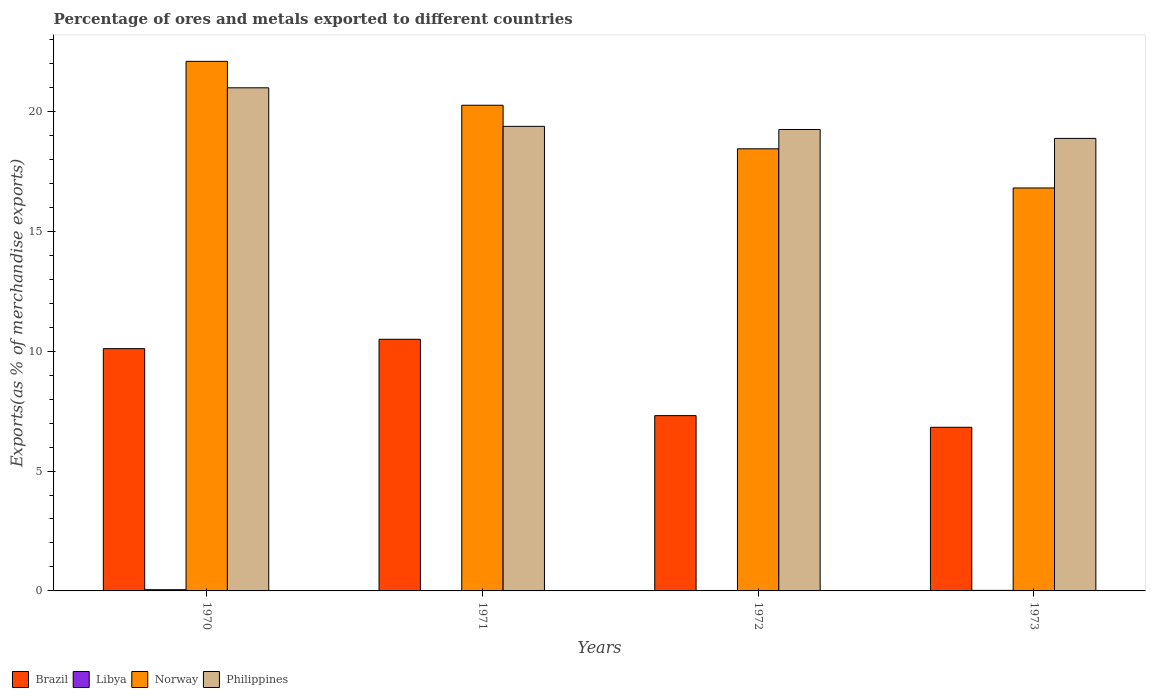How many different coloured bars are there?
Your response must be concise. 4. How many groups of bars are there?
Give a very brief answer. 4. How many bars are there on the 3rd tick from the left?
Your answer should be very brief. 4. What is the label of the 1st group of bars from the left?
Your response must be concise. 1970. What is the percentage of exports to different countries in Brazil in 1972?
Keep it short and to the point. 7.31. Across all years, what is the maximum percentage of exports to different countries in Libya?
Make the answer very short. 0.05. Across all years, what is the minimum percentage of exports to different countries in Philippines?
Make the answer very short. 18.87. In which year was the percentage of exports to different countries in Norway maximum?
Make the answer very short. 1970. What is the total percentage of exports to different countries in Libya in the graph?
Provide a succinct answer. 0.1. What is the difference between the percentage of exports to different countries in Norway in 1972 and that in 1973?
Provide a short and direct response. 1.63. What is the difference between the percentage of exports to different countries in Norway in 1970 and the percentage of exports to different countries in Brazil in 1971?
Keep it short and to the point. 11.59. What is the average percentage of exports to different countries in Philippines per year?
Make the answer very short. 19.62. In the year 1970, what is the difference between the percentage of exports to different countries in Brazil and percentage of exports to different countries in Libya?
Provide a succinct answer. 10.05. In how many years, is the percentage of exports to different countries in Libya greater than 13 %?
Your answer should be very brief. 0. What is the ratio of the percentage of exports to different countries in Philippines in 1970 to that in 1973?
Your answer should be compact. 1.11. Is the percentage of exports to different countries in Philippines in 1971 less than that in 1972?
Give a very brief answer. No. Is the difference between the percentage of exports to different countries in Brazil in 1972 and 1973 greater than the difference between the percentage of exports to different countries in Libya in 1972 and 1973?
Keep it short and to the point. Yes. What is the difference between the highest and the second highest percentage of exports to different countries in Philippines?
Offer a very short reply. 1.61. What is the difference between the highest and the lowest percentage of exports to different countries in Libya?
Provide a succinct answer. 0.05. In how many years, is the percentage of exports to different countries in Libya greater than the average percentage of exports to different countries in Libya taken over all years?
Provide a short and direct response. 1. Is the sum of the percentage of exports to different countries in Libya in 1971 and 1973 greater than the maximum percentage of exports to different countries in Philippines across all years?
Give a very brief answer. No. What does the 2nd bar from the left in 1973 represents?
Make the answer very short. Libya. What does the 3rd bar from the right in 1970 represents?
Provide a succinct answer. Libya. Is it the case that in every year, the sum of the percentage of exports to different countries in Libya and percentage of exports to different countries in Philippines is greater than the percentage of exports to different countries in Brazil?
Give a very brief answer. Yes. How many years are there in the graph?
Your response must be concise. 4. What is the difference between two consecutive major ticks on the Y-axis?
Your response must be concise. 5. Are the values on the major ticks of Y-axis written in scientific E-notation?
Give a very brief answer. No. Where does the legend appear in the graph?
Provide a short and direct response. Bottom left. How many legend labels are there?
Make the answer very short. 4. What is the title of the graph?
Offer a terse response. Percentage of ores and metals exported to different countries. What is the label or title of the X-axis?
Make the answer very short. Years. What is the label or title of the Y-axis?
Your answer should be very brief. Exports(as % of merchandise exports). What is the Exports(as % of merchandise exports) in Brazil in 1970?
Give a very brief answer. 10.11. What is the Exports(as % of merchandise exports) of Libya in 1970?
Your response must be concise. 0.05. What is the Exports(as % of merchandise exports) in Norway in 1970?
Ensure brevity in your answer.  22.09. What is the Exports(as % of merchandise exports) in Philippines in 1970?
Ensure brevity in your answer.  20.98. What is the Exports(as % of merchandise exports) of Brazil in 1971?
Make the answer very short. 10.5. What is the Exports(as % of merchandise exports) in Libya in 1971?
Offer a very short reply. 0. What is the Exports(as % of merchandise exports) of Norway in 1971?
Your answer should be compact. 20.26. What is the Exports(as % of merchandise exports) of Philippines in 1971?
Provide a succinct answer. 19.38. What is the Exports(as % of merchandise exports) of Brazil in 1972?
Keep it short and to the point. 7.31. What is the Exports(as % of merchandise exports) of Libya in 1972?
Your answer should be compact. 0.02. What is the Exports(as % of merchandise exports) in Norway in 1972?
Your response must be concise. 18.44. What is the Exports(as % of merchandise exports) in Philippines in 1972?
Your answer should be compact. 19.25. What is the Exports(as % of merchandise exports) in Brazil in 1973?
Your answer should be very brief. 6.83. What is the Exports(as % of merchandise exports) in Libya in 1973?
Your answer should be very brief. 0.02. What is the Exports(as % of merchandise exports) of Norway in 1973?
Provide a short and direct response. 16.81. What is the Exports(as % of merchandise exports) in Philippines in 1973?
Your response must be concise. 18.87. Across all years, what is the maximum Exports(as % of merchandise exports) in Brazil?
Ensure brevity in your answer.  10.5. Across all years, what is the maximum Exports(as % of merchandise exports) in Libya?
Ensure brevity in your answer.  0.05. Across all years, what is the maximum Exports(as % of merchandise exports) of Norway?
Your answer should be very brief. 22.09. Across all years, what is the maximum Exports(as % of merchandise exports) of Philippines?
Ensure brevity in your answer.  20.98. Across all years, what is the minimum Exports(as % of merchandise exports) of Brazil?
Your response must be concise. 6.83. Across all years, what is the minimum Exports(as % of merchandise exports) in Libya?
Provide a short and direct response. 0. Across all years, what is the minimum Exports(as % of merchandise exports) of Norway?
Your answer should be very brief. 16.81. Across all years, what is the minimum Exports(as % of merchandise exports) in Philippines?
Provide a succinct answer. 18.87. What is the total Exports(as % of merchandise exports) of Brazil in the graph?
Your response must be concise. 34.74. What is the total Exports(as % of merchandise exports) of Libya in the graph?
Keep it short and to the point. 0.1. What is the total Exports(as % of merchandise exports) of Norway in the graph?
Ensure brevity in your answer.  77.59. What is the total Exports(as % of merchandise exports) in Philippines in the graph?
Your answer should be very brief. 78.48. What is the difference between the Exports(as % of merchandise exports) in Brazil in 1970 and that in 1971?
Provide a short and direct response. -0.39. What is the difference between the Exports(as % of merchandise exports) of Libya in 1970 and that in 1971?
Offer a terse response. 0.05. What is the difference between the Exports(as % of merchandise exports) of Norway in 1970 and that in 1971?
Your answer should be very brief. 1.83. What is the difference between the Exports(as % of merchandise exports) in Philippines in 1970 and that in 1971?
Make the answer very short. 1.61. What is the difference between the Exports(as % of merchandise exports) of Brazil in 1970 and that in 1972?
Offer a very short reply. 2.79. What is the difference between the Exports(as % of merchandise exports) in Libya in 1970 and that in 1972?
Ensure brevity in your answer.  0.03. What is the difference between the Exports(as % of merchandise exports) of Norway in 1970 and that in 1972?
Keep it short and to the point. 3.65. What is the difference between the Exports(as % of merchandise exports) in Philippines in 1970 and that in 1972?
Your answer should be very brief. 1.74. What is the difference between the Exports(as % of merchandise exports) of Brazil in 1970 and that in 1973?
Ensure brevity in your answer.  3.28. What is the difference between the Exports(as % of merchandise exports) in Libya in 1970 and that in 1973?
Provide a succinct answer. 0.03. What is the difference between the Exports(as % of merchandise exports) of Norway in 1970 and that in 1973?
Your answer should be compact. 5.28. What is the difference between the Exports(as % of merchandise exports) in Philippines in 1970 and that in 1973?
Ensure brevity in your answer.  2.11. What is the difference between the Exports(as % of merchandise exports) in Brazil in 1971 and that in 1972?
Your answer should be compact. 3.18. What is the difference between the Exports(as % of merchandise exports) in Libya in 1971 and that in 1972?
Make the answer very short. -0.01. What is the difference between the Exports(as % of merchandise exports) of Norway in 1971 and that in 1972?
Give a very brief answer. 1.82. What is the difference between the Exports(as % of merchandise exports) of Philippines in 1971 and that in 1972?
Make the answer very short. 0.13. What is the difference between the Exports(as % of merchandise exports) in Brazil in 1971 and that in 1973?
Your response must be concise. 3.67. What is the difference between the Exports(as % of merchandise exports) of Libya in 1971 and that in 1973?
Keep it short and to the point. -0.02. What is the difference between the Exports(as % of merchandise exports) of Norway in 1971 and that in 1973?
Offer a terse response. 3.45. What is the difference between the Exports(as % of merchandise exports) in Philippines in 1971 and that in 1973?
Offer a terse response. 0.5. What is the difference between the Exports(as % of merchandise exports) of Brazil in 1972 and that in 1973?
Offer a terse response. 0.49. What is the difference between the Exports(as % of merchandise exports) in Libya in 1972 and that in 1973?
Ensure brevity in your answer.  -0. What is the difference between the Exports(as % of merchandise exports) of Norway in 1972 and that in 1973?
Your answer should be very brief. 1.63. What is the difference between the Exports(as % of merchandise exports) in Philippines in 1972 and that in 1973?
Your answer should be compact. 0.37. What is the difference between the Exports(as % of merchandise exports) of Brazil in 1970 and the Exports(as % of merchandise exports) of Libya in 1971?
Ensure brevity in your answer.  10.1. What is the difference between the Exports(as % of merchandise exports) of Brazil in 1970 and the Exports(as % of merchandise exports) of Norway in 1971?
Give a very brief answer. -10.15. What is the difference between the Exports(as % of merchandise exports) of Brazil in 1970 and the Exports(as % of merchandise exports) of Philippines in 1971?
Provide a short and direct response. -9.27. What is the difference between the Exports(as % of merchandise exports) in Libya in 1970 and the Exports(as % of merchandise exports) in Norway in 1971?
Give a very brief answer. -20.21. What is the difference between the Exports(as % of merchandise exports) in Libya in 1970 and the Exports(as % of merchandise exports) in Philippines in 1971?
Ensure brevity in your answer.  -19.33. What is the difference between the Exports(as % of merchandise exports) of Norway in 1970 and the Exports(as % of merchandise exports) of Philippines in 1971?
Keep it short and to the point. 2.71. What is the difference between the Exports(as % of merchandise exports) of Brazil in 1970 and the Exports(as % of merchandise exports) of Libya in 1972?
Your response must be concise. 10.09. What is the difference between the Exports(as % of merchandise exports) of Brazil in 1970 and the Exports(as % of merchandise exports) of Norway in 1972?
Keep it short and to the point. -8.34. What is the difference between the Exports(as % of merchandise exports) in Brazil in 1970 and the Exports(as % of merchandise exports) in Philippines in 1972?
Your answer should be compact. -9.14. What is the difference between the Exports(as % of merchandise exports) in Libya in 1970 and the Exports(as % of merchandise exports) in Norway in 1972?
Offer a terse response. -18.39. What is the difference between the Exports(as % of merchandise exports) in Libya in 1970 and the Exports(as % of merchandise exports) in Philippines in 1972?
Give a very brief answer. -19.19. What is the difference between the Exports(as % of merchandise exports) of Norway in 1970 and the Exports(as % of merchandise exports) of Philippines in 1972?
Give a very brief answer. 2.84. What is the difference between the Exports(as % of merchandise exports) in Brazil in 1970 and the Exports(as % of merchandise exports) in Libya in 1973?
Your answer should be compact. 10.08. What is the difference between the Exports(as % of merchandise exports) in Brazil in 1970 and the Exports(as % of merchandise exports) in Norway in 1973?
Offer a very short reply. -6.7. What is the difference between the Exports(as % of merchandise exports) in Brazil in 1970 and the Exports(as % of merchandise exports) in Philippines in 1973?
Make the answer very short. -8.77. What is the difference between the Exports(as % of merchandise exports) of Libya in 1970 and the Exports(as % of merchandise exports) of Norway in 1973?
Your answer should be compact. -16.75. What is the difference between the Exports(as % of merchandise exports) in Libya in 1970 and the Exports(as % of merchandise exports) in Philippines in 1973?
Provide a succinct answer. -18.82. What is the difference between the Exports(as % of merchandise exports) of Norway in 1970 and the Exports(as % of merchandise exports) of Philippines in 1973?
Provide a succinct answer. 3.21. What is the difference between the Exports(as % of merchandise exports) in Brazil in 1971 and the Exports(as % of merchandise exports) in Libya in 1972?
Provide a short and direct response. 10.48. What is the difference between the Exports(as % of merchandise exports) in Brazil in 1971 and the Exports(as % of merchandise exports) in Norway in 1972?
Keep it short and to the point. -7.94. What is the difference between the Exports(as % of merchandise exports) in Brazil in 1971 and the Exports(as % of merchandise exports) in Philippines in 1972?
Your answer should be compact. -8.75. What is the difference between the Exports(as % of merchandise exports) of Libya in 1971 and the Exports(as % of merchandise exports) of Norway in 1972?
Offer a terse response. -18.44. What is the difference between the Exports(as % of merchandise exports) in Libya in 1971 and the Exports(as % of merchandise exports) in Philippines in 1972?
Ensure brevity in your answer.  -19.24. What is the difference between the Exports(as % of merchandise exports) in Brazil in 1971 and the Exports(as % of merchandise exports) in Libya in 1973?
Your answer should be very brief. 10.47. What is the difference between the Exports(as % of merchandise exports) in Brazil in 1971 and the Exports(as % of merchandise exports) in Norway in 1973?
Make the answer very short. -6.31. What is the difference between the Exports(as % of merchandise exports) in Brazil in 1971 and the Exports(as % of merchandise exports) in Philippines in 1973?
Give a very brief answer. -8.38. What is the difference between the Exports(as % of merchandise exports) in Libya in 1971 and the Exports(as % of merchandise exports) in Norway in 1973?
Provide a succinct answer. -16.8. What is the difference between the Exports(as % of merchandise exports) in Libya in 1971 and the Exports(as % of merchandise exports) in Philippines in 1973?
Give a very brief answer. -18.87. What is the difference between the Exports(as % of merchandise exports) of Norway in 1971 and the Exports(as % of merchandise exports) of Philippines in 1973?
Your response must be concise. 1.38. What is the difference between the Exports(as % of merchandise exports) of Brazil in 1972 and the Exports(as % of merchandise exports) of Libya in 1973?
Give a very brief answer. 7.29. What is the difference between the Exports(as % of merchandise exports) in Brazil in 1972 and the Exports(as % of merchandise exports) in Norway in 1973?
Give a very brief answer. -9.49. What is the difference between the Exports(as % of merchandise exports) in Brazil in 1972 and the Exports(as % of merchandise exports) in Philippines in 1973?
Offer a terse response. -11.56. What is the difference between the Exports(as % of merchandise exports) in Libya in 1972 and the Exports(as % of merchandise exports) in Norway in 1973?
Offer a terse response. -16.79. What is the difference between the Exports(as % of merchandise exports) in Libya in 1972 and the Exports(as % of merchandise exports) in Philippines in 1973?
Ensure brevity in your answer.  -18.86. What is the difference between the Exports(as % of merchandise exports) of Norway in 1972 and the Exports(as % of merchandise exports) of Philippines in 1973?
Provide a succinct answer. -0.43. What is the average Exports(as % of merchandise exports) in Brazil per year?
Your response must be concise. 8.68. What is the average Exports(as % of merchandise exports) of Libya per year?
Give a very brief answer. 0.02. What is the average Exports(as % of merchandise exports) of Norway per year?
Your answer should be compact. 19.4. What is the average Exports(as % of merchandise exports) of Philippines per year?
Make the answer very short. 19.62. In the year 1970, what is the difference between the Exports(as % of merchandise exports) in Brazil and Exports(as % of merchandise exports) in Libya?
Provide a succinct answer. 10.05. In the year 1970, what is the difference between the Exports(as % of merchandise exports) of Brazil and Exports(as % of merchandise exports) of Norway?
Your response must be concise. -11.98. In the year 1970, what is the difference between the Exports(as % of merchandise exports) of Brazil and Exports(as % of merchandise exports) of Philippines?
Your response must be concise. -10.88. In the year 1970, what is the difference between the Exports(as % of merchandise exports) of Libya and Exports(as % of merchandise exports) of Norway?
Your answer should be compact. -22.04. In the year 1970, what is the difference between the Exports(as % of merchandise exports) in Libya and Exports(as % of merchandise exports) in Philippines?
Your answer should be compact. -20.93. In the year 1970, what is the difference between the Exports(as % of merchandise exports) in Norway and Exports(as % of merchandise exports) in Philippines?
Your response must be concise. 1.1. In the year 1971, what is the difference between the Exports(as % of merchandise exports) in Brazil and Exports(as % of merchandise exports) in Libya?
Your answer should be compact. 10.49. In the year 1971, what is the difference between the Exports(as % of merchandise exports) in Brazil and Exports(as % of merchandise exports) in Norway?
Your answer should be compact. -9.76. In the year 1971, what is the difference between the Exports(as % of merchandise exports) of Brazil and Exports(as % of merchandise exports) of Philippines?
Offer a very short reply. -8.88. In the year 1971, what is the difference between the Exports(as % of merchandise exports) in Libya and Exports(as % of merchandise exports) in Norway?
Ensure brevity in your answer.  -20.25. In the year 1971, what is the difference between the Exports(as % of merchandise exports) in Libya and Exports(as % of merchandise exports) in Philippines?
Provide a short and direct response. -19.37. In the year 1971, what is the difference between the Exports(as % of merchandise exports) in Norway and Exports(as % of merchandise exports) in Philippines?
Ensure brevity in your answer.  0.88. In the year 1972, what is the difference between the Exports(as % of merchandise exports) in Brazil and Exports(as % of merchandise exports) in Libya?
Your answer should be compact. 7.29. In the year 1972, what is the difference between the Exports(as % of merchandise exports) in Brazil and Exports(as % of merchandise exports) in Norway?
Provide a short and direct response. -11.13. In the year 1972, what is the difference between the Exports(as % of merchandise exports) of Brazil and Exports(as % of merchandise exports) of Philippines?
Offer a terse response. -11.93. In the year 1972, what is the difference between the Exports(as % of merchandise exports) in Libya and Exports(as % of merchandise exports) in Norway?
Your answer should be compact. -18.42. In the year 1972, what is the difference between the Exports(as % of merchandise exports) in Libya and Exports(as % of merchandise exports) in Philippines?
Offer a very short reply. -19.23. In the year 1972, what is the difference between the Exports(as % of merchandise exports) in Norway and Exports(as % of merchandise exports) in Philippines?
Offer a terse response. -0.81. In the year 1973, what is the difference between the Exports(as % of merchandise exports) in Brazil and Exports(as % of merchandise exports) in Libya?
Provide a succinct answer. 6.8. In the year 1973, what is the difference between the Exports(as % of merchandise exports) in Brazil and Exports(as % of merchandise exports) in Norway?
Offer a very short reply. -9.98. In the year 1973, what is the difference between the Exports(as % of merchandise exports) of Brazil and Exports(as % of merchandise exports) of Philippines?
Your answer should be compact. -12.05. In the year 1973, what is the difference between the Exports(as % of merchandise exports) in Libya and Exports(as % of merchandise exports) in Norway?
Keep it short and to the point. -16.78. In the year 1973, what is the difference between the Exports(as % of merchandise exports) of Libya and Exports(as % of merchandise exports) of Philippines?
Provide a succinct answer. -18.85. In the year 1973, what is the difference between the Exports(as % of merchandise exports) in Norway and Exports(as % of merchandise exports) in Philippines?
Offer a terse response. -2.07. What is the ratio of the Exports(as % of merchandise exports) in Brazil in 1970 to that in 1971?
Provide a short and direct response. 0.96. What is the ratio of the Exports(as % of merchandise exports) in Libya in 1970 to that in 1971?
Provide a short and direct response. 12.08. What is the ratio of the Exports(as % of merchandise exports) of Norway in 1970 to that in 1971?
Provide a short and direct response. 1.09. What is the ratio of the Exports(as % of merchandise exports) in Philippines in 1970 to that in 1971?
Ensure brevity in your answer.  1.08. What is the ratio of the Exports(as % of merchandise exports) of Brazil in 1970 to that in 1972?
Your response must be concise. 1.38. What is the ratio of the Exports(as % of merchandise exports) of Libya in 1970 to that in 1972?
Make the answer very short. 2.74. What is the ratio of the Exports(as % of merchandise exports) in Norway in 1970 to that in 1972?
Give a very brief answer. 1.2. What is the ratio of the Exports(as % of merchandise exports) of Philippines in 1970 to that in 1972?
Your response must be concise. 1.09. What is the ratio of the Exports(as % of merchandise exports) in Brazil in 1970 to that in 1973?
Your answer should be very brief. 1.48. What is the ratio of the Exports(as % of merchandise exports) of Libya in 1970 to that in 1973?
Keep it short and to the point. 2.18. What is the ratio of the Exports(as % of merchandise exports) in Norway in 1970 to that in 1973?
Your answer should be compact. 1.31. What is the ratio of the Exports(as % of merchandise exports) of Philippines in 1970 to that in 1973?
Keep it short and to the point. 1.11. What is the ratio of the Exports(as % of merchandise exports) in Brazil in 1971 to that in 1972?
Your answer should be very brief. 1.44. What is the ratio of the Exports(as % of merchandise exports) of Libya in 1971 to that in 1972?
Provide a succinct answer. 0.23. What is the ratio of the Exports(as % of merchandise exports) of Norway in 1971 to that in 1972?
Your answer should be compact. 1.1. What is the ratio of the Exports(as % of merchandise exports) of Philippines in 1971 to that in 1972?
Give a very brief answer. 1.01. What is the ratio of the Exports(as % of merchandise exports) in Brazil in 1971 to that in 1973?
Make the answer very short. 1.54. What is the ratio of the Exports(as % of merchandise exports) in Libya in 1971 to that in 1973?
Give a very brief answer. 0.18. What is the ratio of the Exports(as % of merchandise exports) of Norway in 1971 to that in 1973?
Give a very brief answer. 1.21. What is the ratio of the Exports(as % of merchandise exports) of Philippines in 1971 to that in 1973?
Ensure brevity in your answer.  1.03. What is the ratio of the Exports(as % of merchandise exports) of Brazil in 1972 to that in 1973?
Your response must be concise. 1.07. What is the ratio of the Exports(as % of merchandise exports) in Libya in 1972 to that in 1973?
Provide a succinct answer. 0.8. What is the ratio of the Exports(as % of merchandise exports) of Norway in 1972 to that in 1973?
Your response must be concise. 1.1. What is the ratio of the Exports(as % of merchandise exports) in Philippines in 1972 to that in 1973?
Offer a terse response. 1.02. What is the difference between the highest and the second highest Exports(as % of merchandise exports) of Brazil?
Your answer should be compact. 0.39. What is the difference between the highest and the second highest Exports(as % of merchandise exports) in Libya?
Offer a very short reply. 0.03. What is the difference between the highest and the second highest Exports(as % of merchandise exports) in Norway?
Your response must be concise. 1.83. What is the difference between the highest and the second highest Exports(as % of merchandise exports) of Philippines?
Provide a short and direct response. 1.61. What is the difference between the highest and the lowest Exports(as % of merchandise exports) of Brazil?
Make the answer very short. 3.67. What is the difference between the highest and the lowest Exports(as % of merchandise exports) in Libya?
Ensure brevity in your answer.  0.05. What is the difference between the highest and the lowest Exports(as % of merchandise exports) of Norway?
Give a very brief answer. 5.28. What is the difference between the highest and the lowest Exports(as % of merchandise exports) in Philippines?
Your answer should be compact. 2.11. 